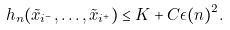Convert formula to latex. <formula><loc_0><loc_0><loc_500><loc_500>h _ { n } ( \tilde { x } _ { i ^ { - } } , \dots , \tilde { x } _ { i ^ { + } } ) \leq K + C \epsilon ( n ) ^ { 2 } .</formula> 